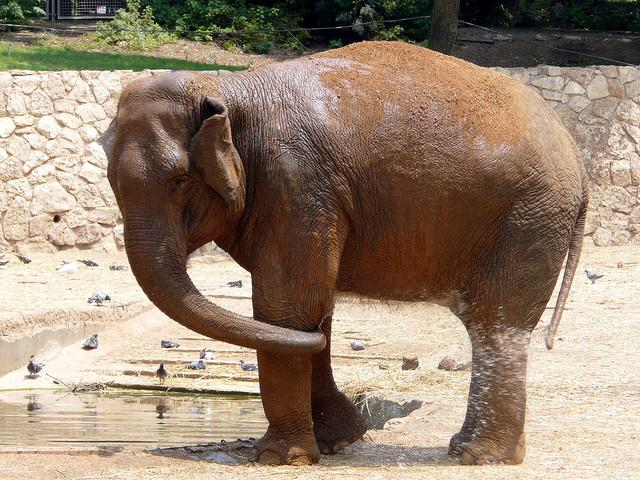Why do hunters hunt this animal? tusks 